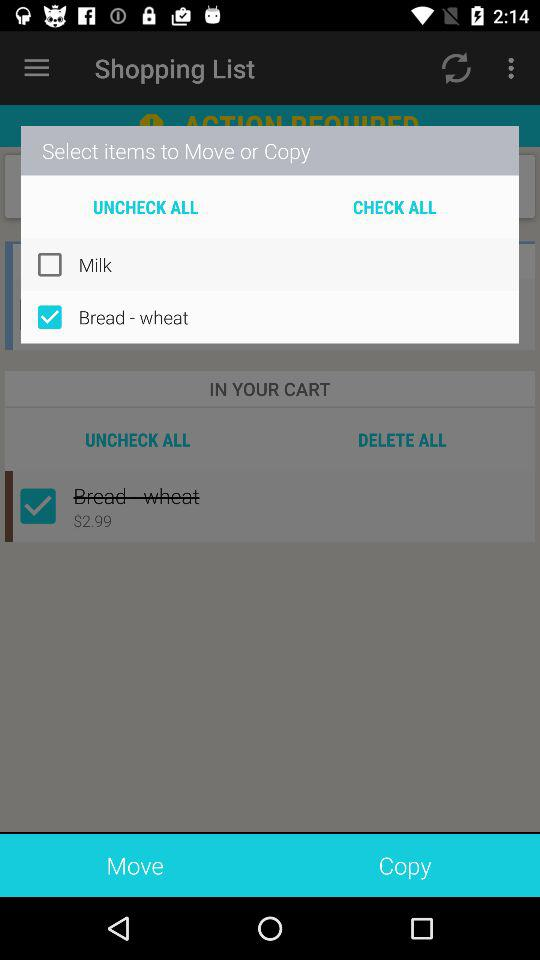Is "Milk" checked or not?
Answer the question using a single word or phrase. "Milk" is unchecked. 